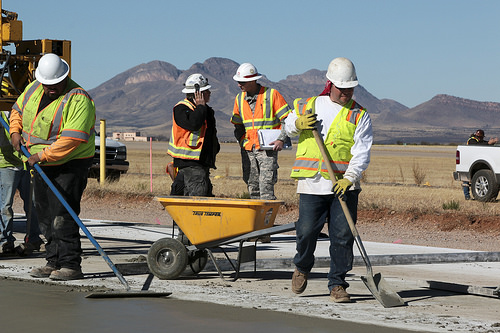<image>
Is the orange man behind the lime man? Yes. From this viewpoint, the orange man is positioned behind the lime man, with the lime man partially or fully occluding the orange man. 